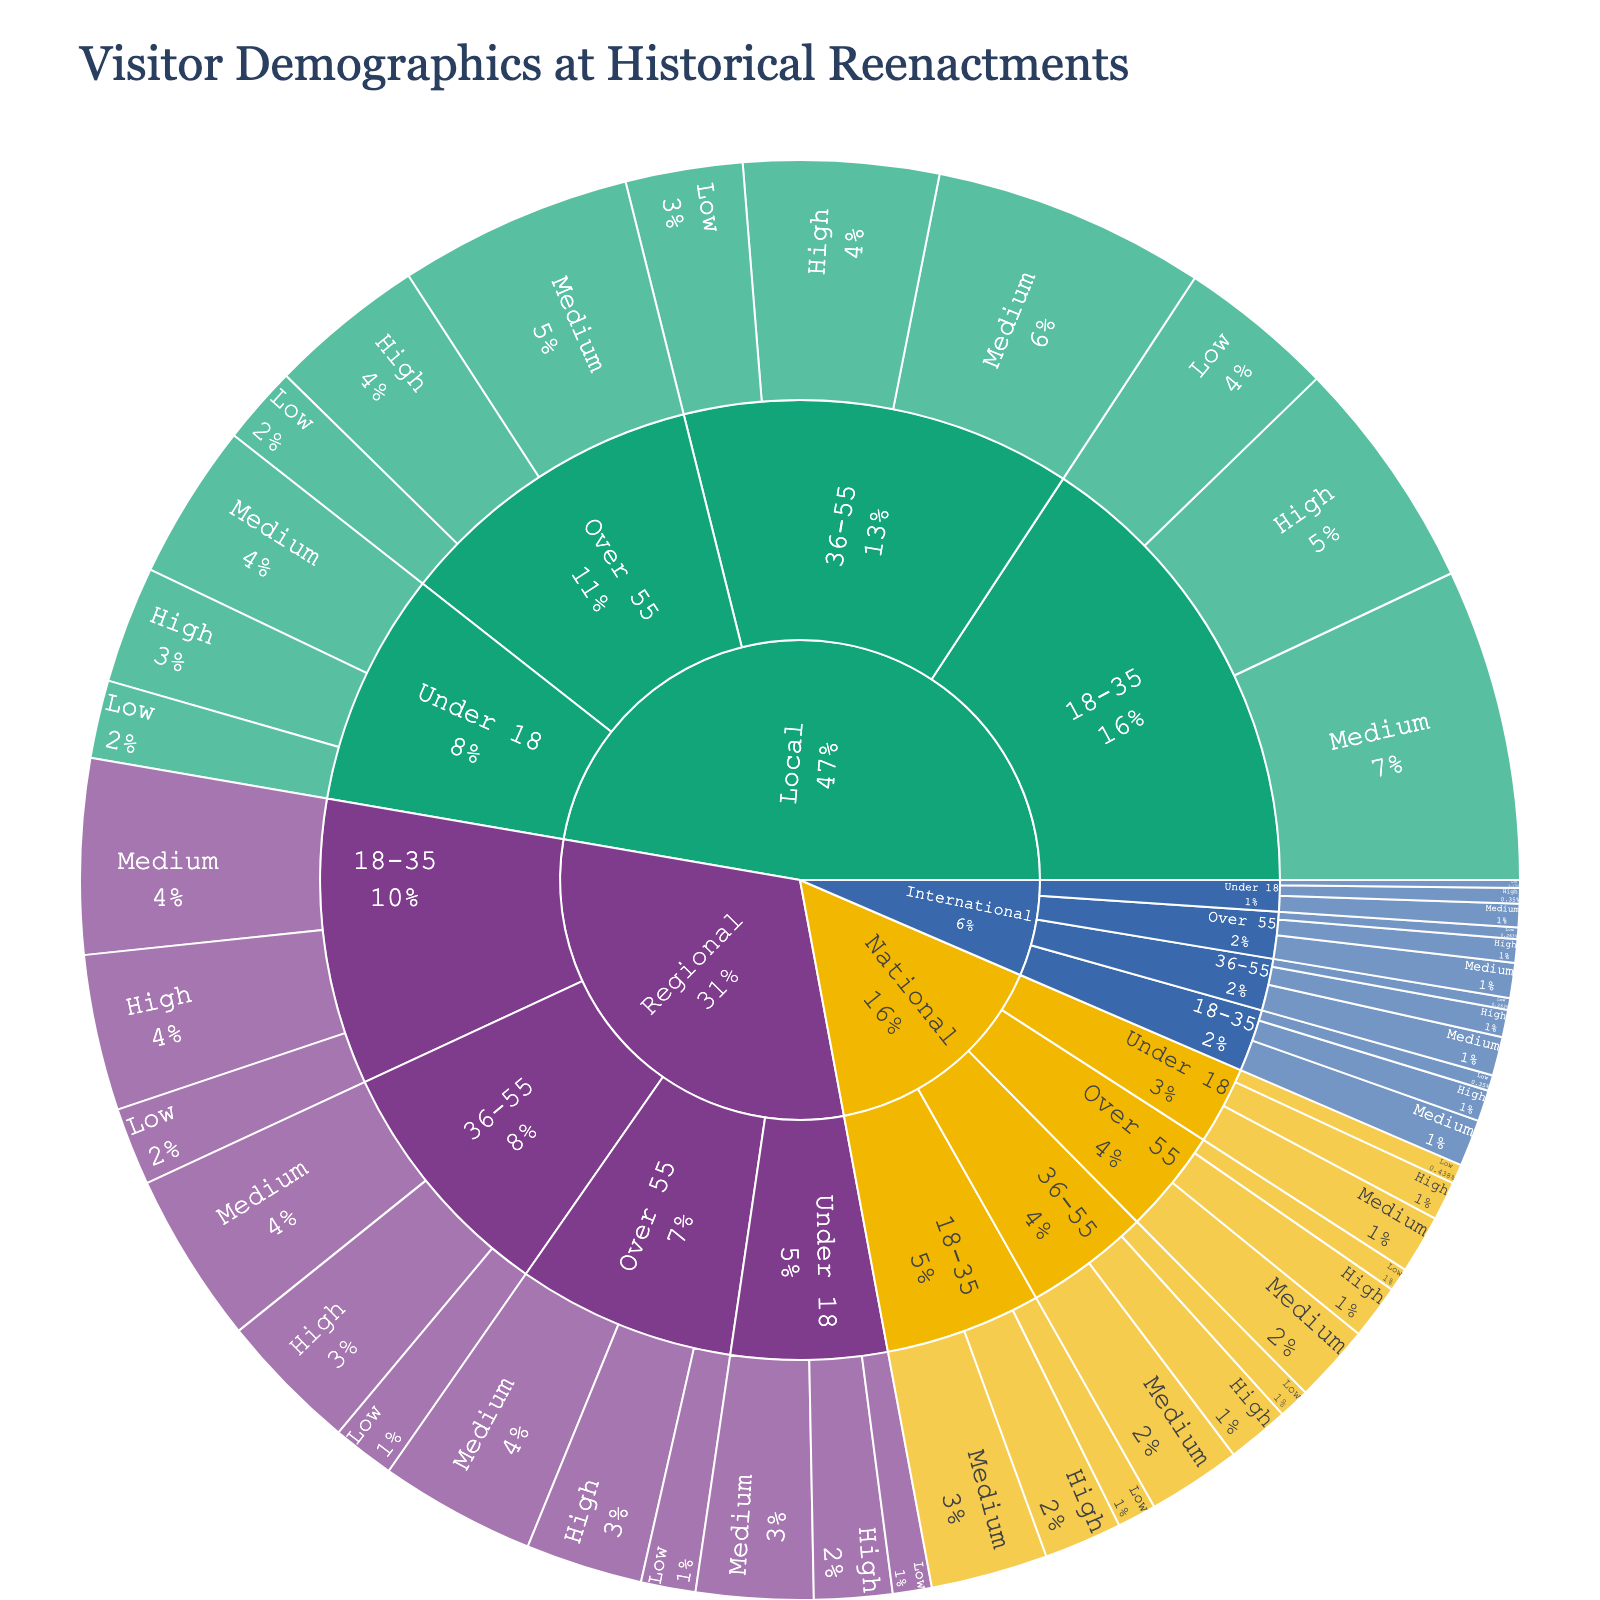What is the title of the plot? The title of the plot is usually available at the top of the figure. It describes what the plot represents.
Answer: Visitor Demographics at Historical Reenactments Which origin has the highest overall number of visitors? By looking at the proportion of each origin segment, the one with the largest section will have the highest number of visitors.
Answer: Local How many visitors are under 18 with a high interest level coming from National origin? Find the National origin section, then look for the Under 18 segment with a high interest level, and read the value.
Answer: 50 What percentage of visitors from the 18-35 age group have a medium interest level coming from Local origin? Locate the Local origin section, then find the 18-35 age group, and identify the medium interest segment. The percentage will be displayed in that section of the sunburst plot.
Answer: ~30.77% What is the total number of visitors from Regional origin across all age groups and interest levels? Sum up the counts from all segments under Regional origin for all combinations of age group and interest level.
Answer: 1,500 How does the number of visitors over 55 from International origin compare to those from National origin? Find the Over 55 segments for both International and National origins, then compare the values. International: 30 (High) + 45 (Medium) + 15 (Low) = 90, National: 70 (High) + 100 (Medium) + 30 (Low) = 200.
Answer: National has more Which age group has the highest number of visitors within the Local origin with a medium interest level? Look at the Local origin section, then compare the segments for each age group within the medium interest level and observe which has the largest count.
Answer: 18-35 Are there more visitors with high or low interest levels from the 36-55 age group within the Regional origin? Compare the high interest (180) and low interest (80) segments under the 36-55 age group in the Regional origin section.
Answer: High What is the combined number of visitors from the Under 18 age group with a high interest level across all origins? Sum up the visitors across all origins for the Under 18 age group with a high interest level. Local: 150, Regional: 100, National: 50, International: 20. Total: 150 + 100 + 50 + 20.
Answer: 320 Which origin has the least number of visitors with a high interest level in the 18-35 age group? Look at the 18-35 age group for each origin and compare the high interest level segments.
Answer: International 